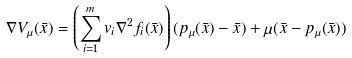Convert formula to latex. <formula><loc_0><loc_0><loc_500><loc_500>\nabla V _ { \mu } ( \bar { x } ) = \left ( \sum _ { i = 1 } ^ { m } v _ { i } \nabla ^ { 2 } f _ { i } ( \bar { x } ) \right ) ( p _ { \mu } ( \bar { x } ) - \bar { x } ) + \mu ( \bar { x } - p _ { \mu } ( \bar { x } ) )</formula> 